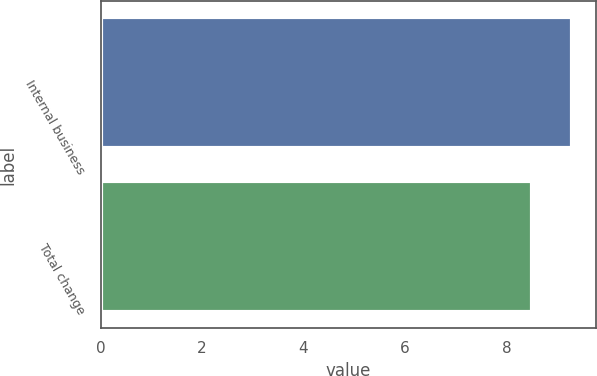Convert chart to OTSL. <chart><loc_0><loc_0><loc_500><loc_500><bar_chart><fcel>Internal business<fcel>Total change<nl><fcel>9.3<fcel>8.5<nl></chart> 